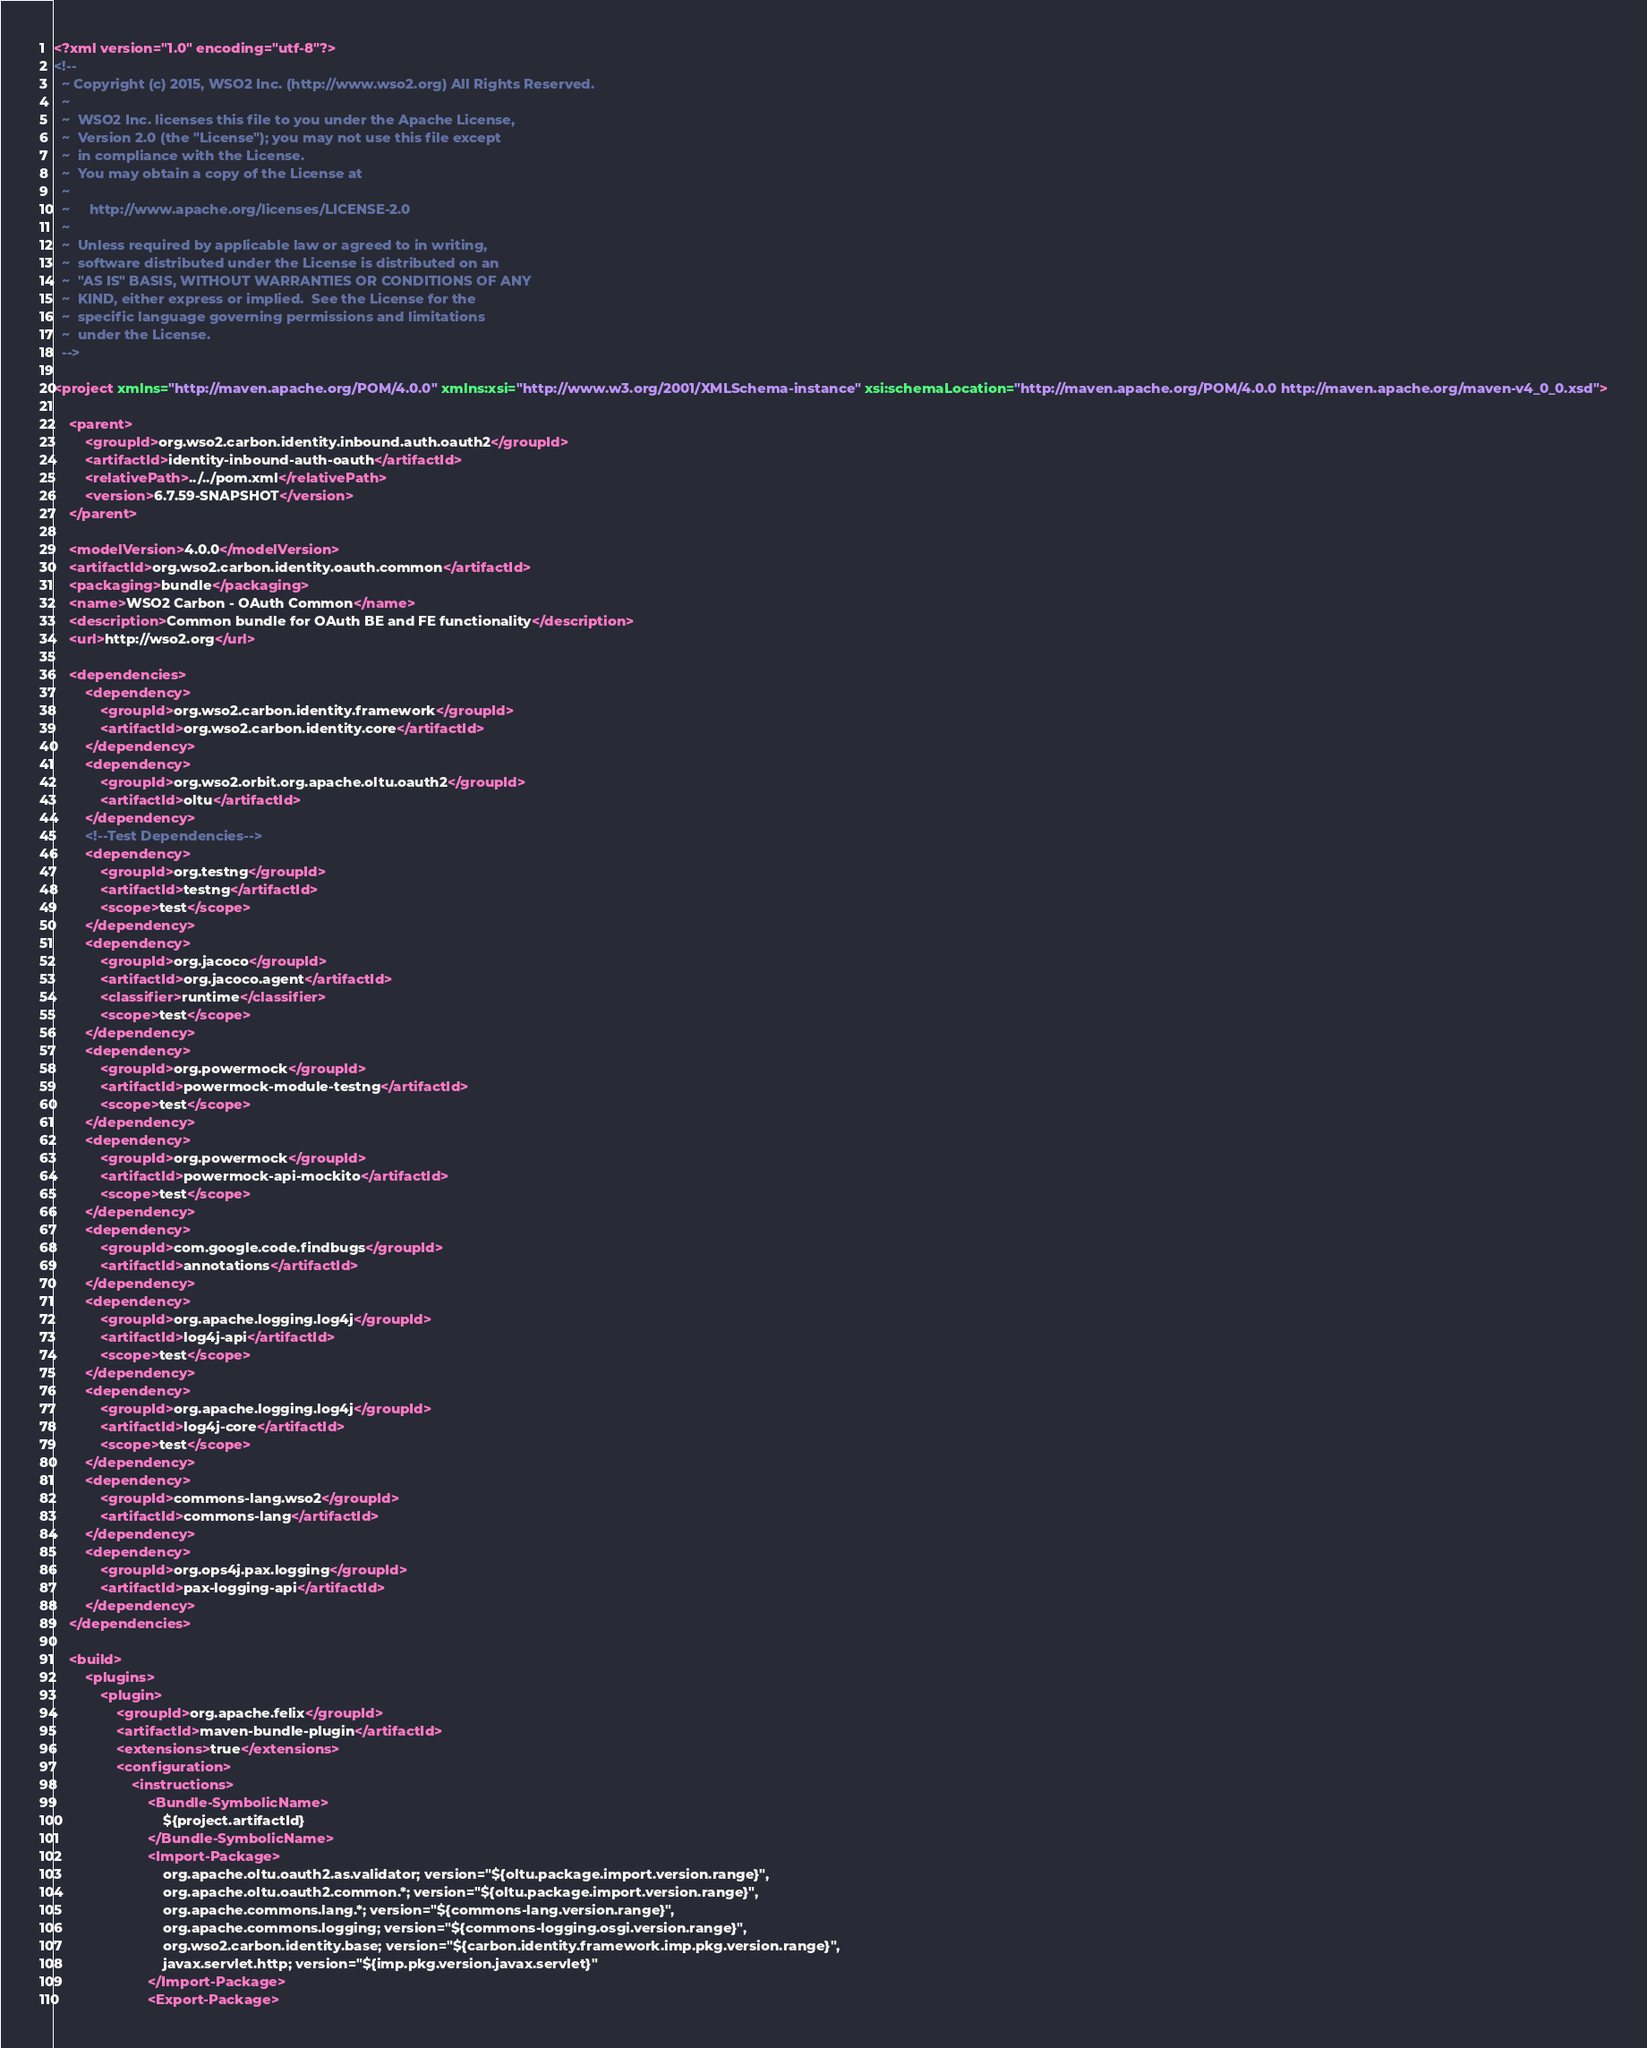<code> <loc_0><loc_0><loc_500><loc_500><_XML_><?xml version="1.0" encoding="utf-8"?>
<!--
  ~ Copyright (c) 2015, WSO2 Inc. (http://www.wso2.org) All Rights Reserved.
  ~
  ~  WSO2 Inc. licenses this file to you under the Apache License,
  ~  Version 2.0 (the "License"); you may not use this file except
  ~  in compliance with the License.
  ~  You may obtain a copy of the License at
  ~
  ~     http://www.apache.org/licenses/LICENSE-2.0
  ~
  ~  Unless required by applicable law or agreed to in writing,
  ~  software distributed under the License is distributed on an
  ~  "AS IS" BASIS, WITHOUT WARRANTIES OR CONDITIONS OF ANY
  ~  KIND, either express or implied.  See the License for the
  ~  specific language governing permissions and limitations
  ~  under the License.
  -->

<project xmlns="http://maven.apache.org/POM/4.0.0" xmlns:xsi="http://www.w3.org/2001/XMLSchema-instance" xsi:schemaLocation="http://maven.apache.org/POM/4.0.0 http://maven.apache.org/maven-v4_0_0.xsd">

    <parent>
        <groupId>org.wso2.carbon.identity.inbound.auth.oauth2</groupId>
        <artifactId>identity-inbound-auth-oauth</artifactId>
        <relativePath>../../pom.xml</relativePath>
        <version>6.7.59-SNAPSHOT</version>
    </parent>

    <modelVersion>4.0.0</modelVersion>
    <artifactId>org.wso2.carbon.identity.oauth.common</artifactId>
    <packaging>bundle</packaging>
    <name>WSO2 Carbon - OAuth Common</name>
    <description>Common bundle for OAuth BE and FE functionality</description>
    <url>http://wso2.org</url>

    <dependencies>
        <dependency>
            <groupId>org.wso2.carbon.identity.framework</groupId>
            <artifactId>org.wso2.carbon.identity.core</artifactId>
        </dependency>
        <dependency>
            <groupId>org.wso2.orbit.org.apache.oltu.oauth2</groupId>
            <artifactId>oltu</artifactId>
        </dependency>
        <!--Test Dependencies-->
        <dependency>
            <groupId>org.testng</groupId>
            <artifactId>testng</artifactId>
            <scope>test</scope>
        </dependency>
        <dependency>
            <groupId>org.jacoco</groupId>
            <artifactId>org.jacoco.agent</artifactId>
            <classifier>runtime</classifier>
            <scope>test</scope>
        </dependency>
        <dependency>
            <groupId>org.powermock</groupId>
            <artifactId>powermock-module-testng</artifactId>
            <scope>test</scope>
        </dependency>
        <dependency>
            <groupId>org.powermock</groupId>
            <artifactId>powermock-api-mockito</artifactId>
            <scope>test</scope>
        </dependency>
        <dependency>
            <groupId>com.google.code.findbugs</groupId>
            <artifactId>annotations</artifactId>
        </dependency>
        <dependency>
            <groupId>org.apache.logging.log4j</groupId>
            <artifactId>log4j-api</artifactId>
            <scope>test</scope>
        </dependency>
        <dependency>
            <groupId>org.apache.logging.log4j</groupId>
            <artifactId>log4j-core</artifactId>
            <scope>test</scope>
        </dependency>
        <dependency>
            <groupId>commons-lang.wso2</groupId>
            <artifactId>commons-lang</artifactId>
        </dependency>
        <dependency>
            <groupId>org.ops4j.pax.logging</groupId>
            <artifactId>pax-logging-api</artifactId>
        </dependency>
    </dependencies>

    <build>
        <plugins>
            <plugin>
                <groupId>org.apache.felix</groupId>
                <artifactId>maven-bundle-plugin</artifactId>
                <extensions>true</extensions>
                <configuration>
                    <instructions>
                        <Bundle-SymbolicName>
                            ${project.artifactId}
                        </Bundle-SymbolicName>
                        <Import-Package>
                            org.apache.oltu.oauth2.as.validator; version="${oltu.package.import.version.range}",
                            org.apache.oltu.oauth2.common.*; version="${oltu.package.import.version.range}",
                            org.apache.commons.lang.*; version="${commons-lang.version.range}",
                            org.apache.commons.logging; version="${commons-logging.osgi.version.range}",
                            org.wso2.carbon.identity.base; version="${carbon.identity.framework.imp.pkg.version.range}",
                            javax.servlet.http; version="${imp.pkg.version.javax.servlet}"
                        </Import-Package>
                        <Export-Package></code> 